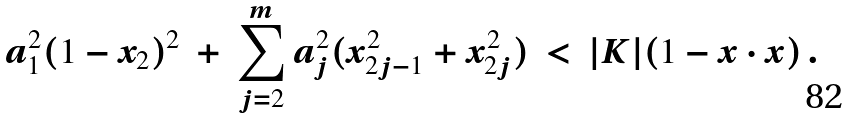Convert formula to latex. <formula><loc_0><loc_0><loc_500><loc_500>a _ { 1 } ^ { 2 } ( 1 - x _ { 2 } ) ^ { 2 } \ + \ \sum _ { j = 2 } ^ { m } a _ { j } ^ { 2 } ( x _ { 2 j - 1 } ^ { 2 } + x _ { 2 j } ^ { 2 } ) \ < \ | K | ( 1 - x \cdot x ) \, .</formula> 